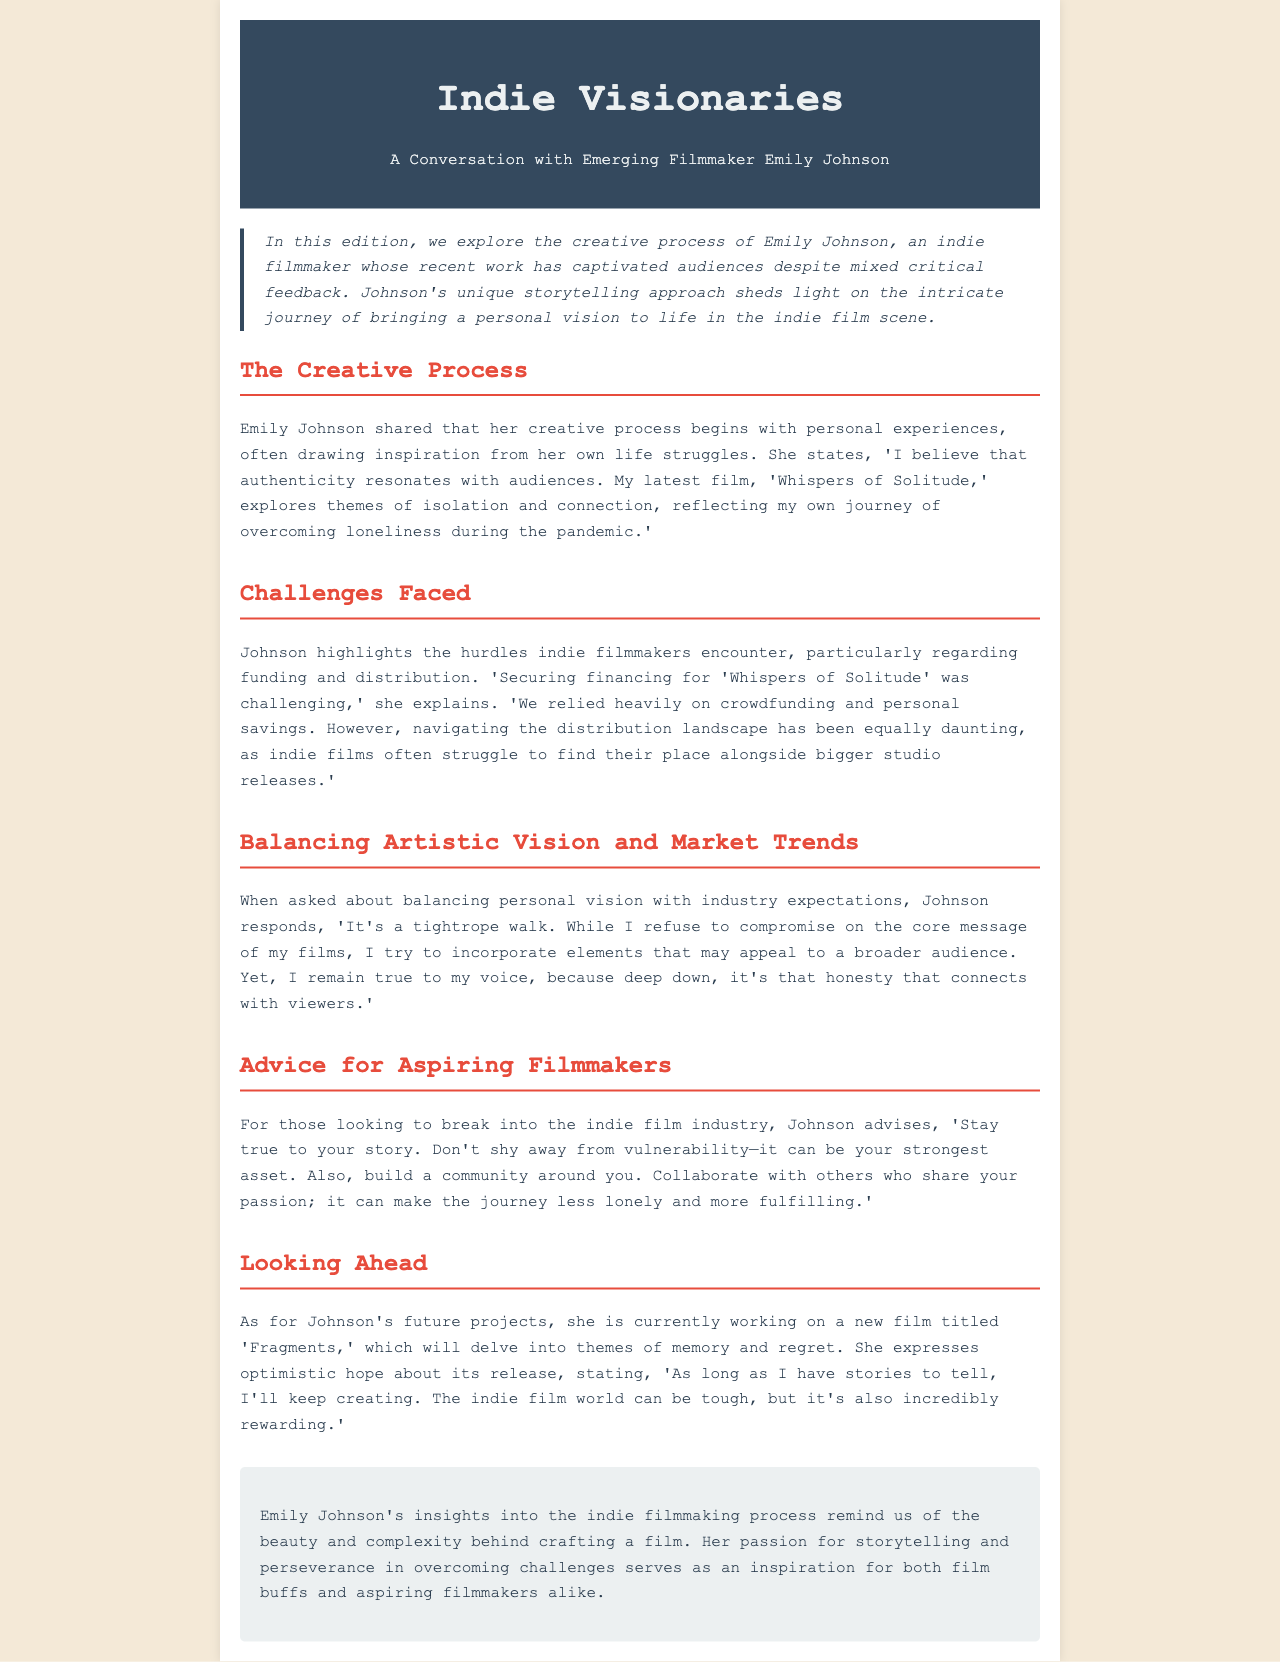What is the title of Emily Johnson's latest film? The title of her latest film is found in the section discussing her creative process, where she mentions, "My latest film, 'Whispers of Solitude,'".
Answer: Whispers of Solitude What major theme does 'Whispers of Solitude' explore? The theme is stated in the creative process section where she discusses her film, reflecting her journey during the pandemic.
Answer: Isolation and connection What funding methods did Emily Johnson utilize for her film? Johnson mentions in the challenges section that she relied on crowdfunding and personal savings for financing.
Answer: Crowdfunding and personal savings What does Emily Johnson advise aspiring filmmakers to do? Johnson provides advice in a specific section for those looking to break into the industry, emphasizing authenticity and community building.
Answer: Stay true to your story What future project is Emily Johnson currently working on? Her future project is mentioned in the looking ahead section, where she discusses her next film.
Answer: Fragments How does Emily Johnson perceive the indie film industry's challenges? She shares her views in the challenges section of the interview about the difficulties in financing and distribution.
Answer: Daunting What is the primary message that Emily Johnson refuses to compromise on? The primary message she refers to in balancing artistic vision and market trends.
Answer: Core message What does Johnson hope for the release of her upcoming film? Her optimistic view on the future is expressed in the looking ahead section of the document.
Answer: Hopeful 